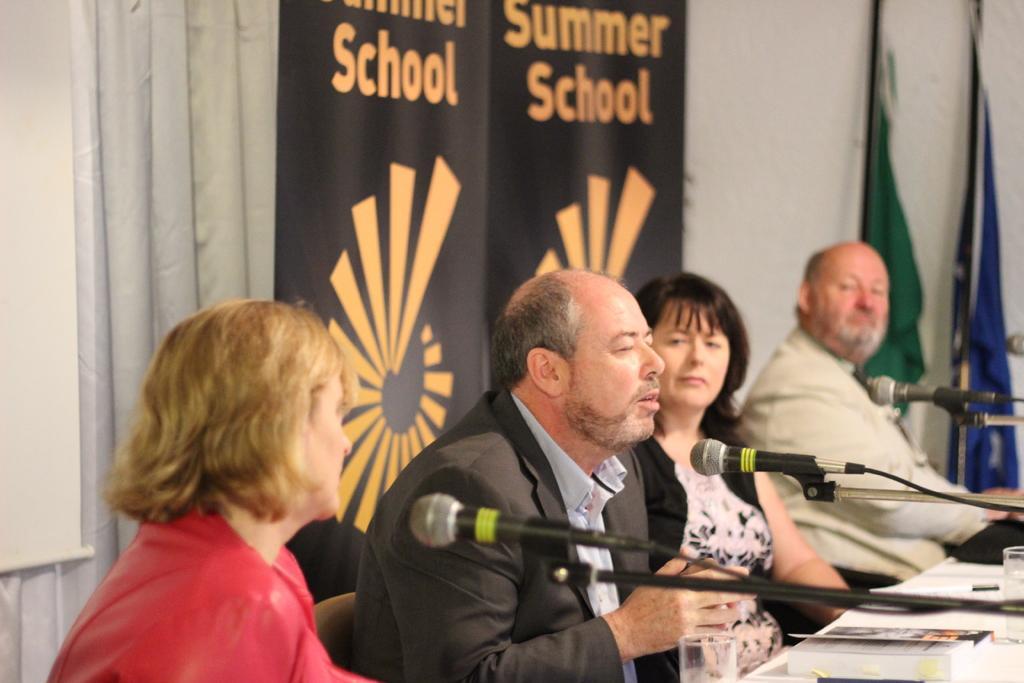How would you summarize this image in a sentence or two? In the image there are few people sitting. In front of them there is a table with glasses, books and stands with mics. Behind them there are banners, curtains and on the left corner of the image there is a screen. In the background there are poles with flags.  